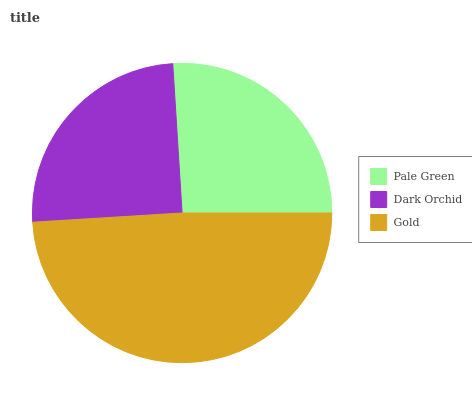Is Dark Orchid the minimum?
Answer yes or no. Yes. Is Gold the maximum?
Answer yes or no. Yes. Is Gold the minimum?
Answer yes or no. No. Is Dark Orchid the maximum?
Answer yes or no. No. Is Gold greater than Dark Orchid?
Answer yes or no. Yes. Is Dark Orchid less than Gold?
Answer yes or no. Yes. Is Dark Orchid greater than Gold?
Answer yes or no. No. Is Gold less than Dark Orchid?
Answer yes or no. No. Is Pale Green the high median?
Answer yes or no. Yes. Is Pale Green the low median?
Answer yes or no. Yes. Is Dark Orchid the high median?
Answer yes or no. No. Is Dark Orchid the low median?
Answer yes or no. No. 